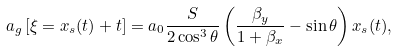<formula> <loc_0><loc_0><loc_500><loc_500>a _ { g } \left [ \xi = x _ { s } ( t ) + t \right ] = a _ { 0 } \frac { S } { 2 \cos ^ { 3 } \theta } \left ( \frac { \beta _ { y } } { 1 + \beta _ { x } } - \sin \theta \right ) x _ { s } ( t ) ,</formula> 